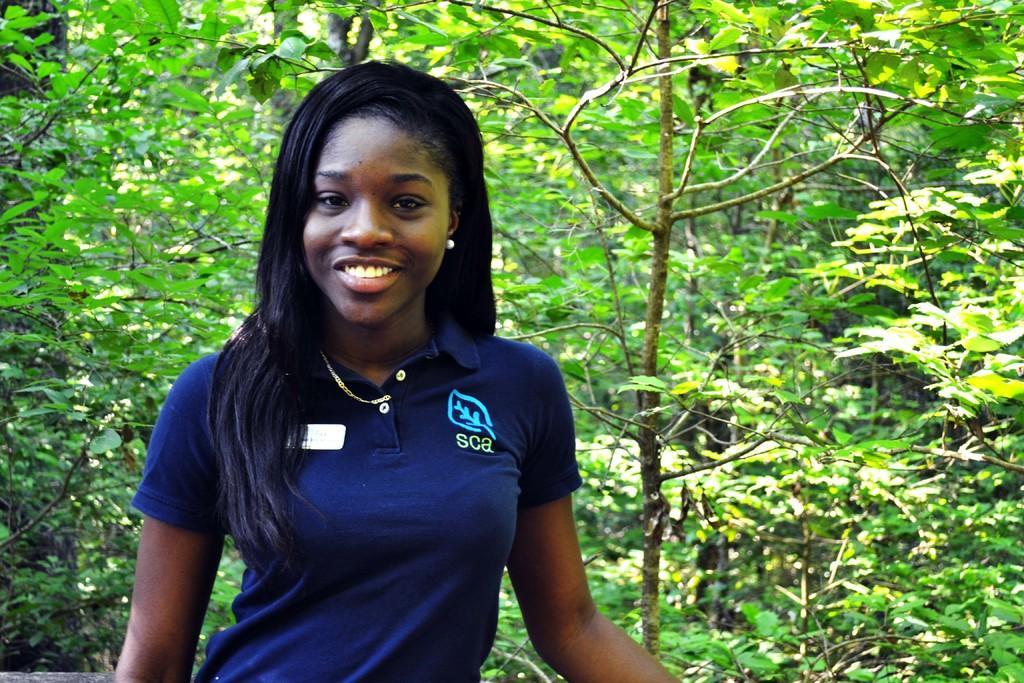Could you give a brief overview of what you see in this image? In this image we can see one woman. And we can see the surrounding trees. 